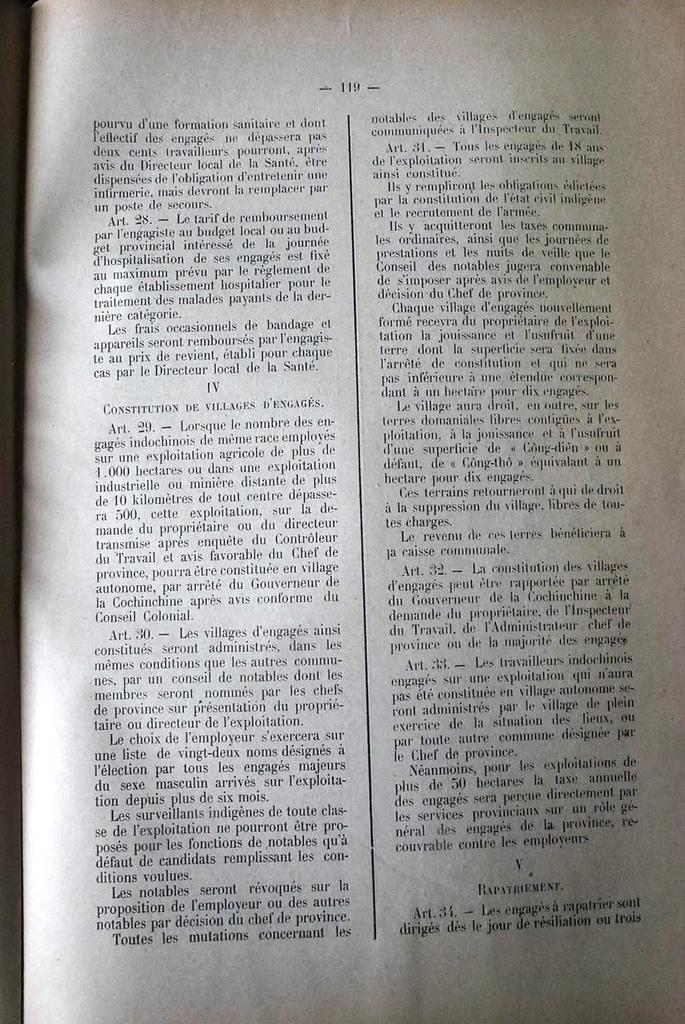<image>
Give a short and clear explanation of the subsequent image. A old book lays open to page 119 